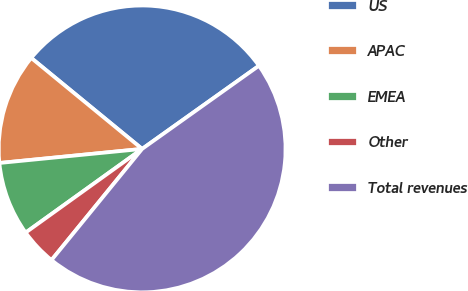Convert chart to OTSL. <chart><loc_0><loc_0><loc_500><loc_500><pie_chart><fcel>US<fcel>APAC<fcel>EMEA<fcel>Other<fcel>Total revenues<nl><fcel>29.22%<fcel>12.5%<fcel>8.35%<fcel>4.2%<fcel>45.73%<nl></chart> 